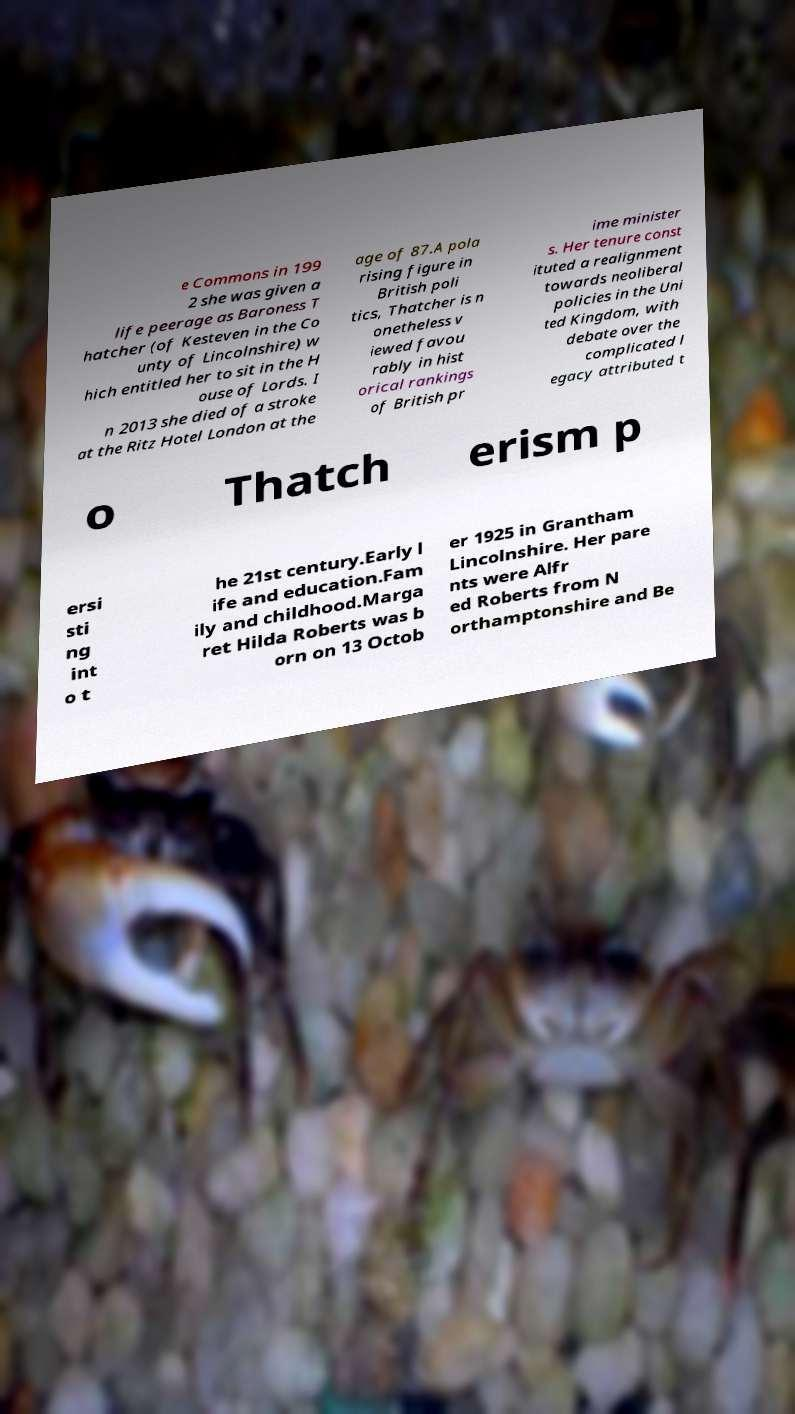Can you accurately transcribe the text from the provided image for me? e Commons in 199 2 she was given a life peerage as Baroness T hatcher (of Kesteven in the Co unty of Lincolnshire) w hich entitled her to sit in the H ouse of Lords. I n 2013 she died of a stroke at the Ritz Hotel London at the age of 87.A pola rising figure in British poli tics, Thatcher is n onetheless v iewed favou rably in hist orical rankings of British pr ime minister s. Her tenure const ituted a realignment towards neoliberal policies in the Uni ted Kingdom, with debate over the complicated l egacy attributed t o Thatch erism p ersi sti ng int o t he 21st century.Early l ife and education.Fam ily and childhood.Marga ret Hilda Roberts was b orn on 13 Octob er 1925 in Grantham Lincolnshire. Her pare nts were Alfr ed Roberts from N orthamptonshire and Be 